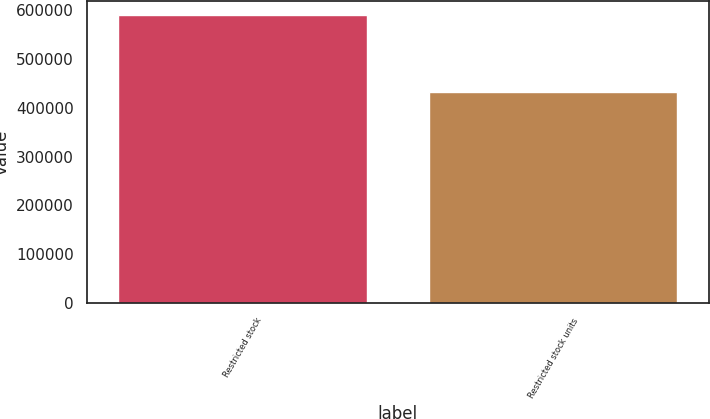Convert chart to OTSL. <chart><loc_0><loc_0><loc_500><loc_500><bar_chart><fcel>Restricted stock<fcel>Restricted stock units<nl><fcel>589150<fcel>432700<nl></chart> 